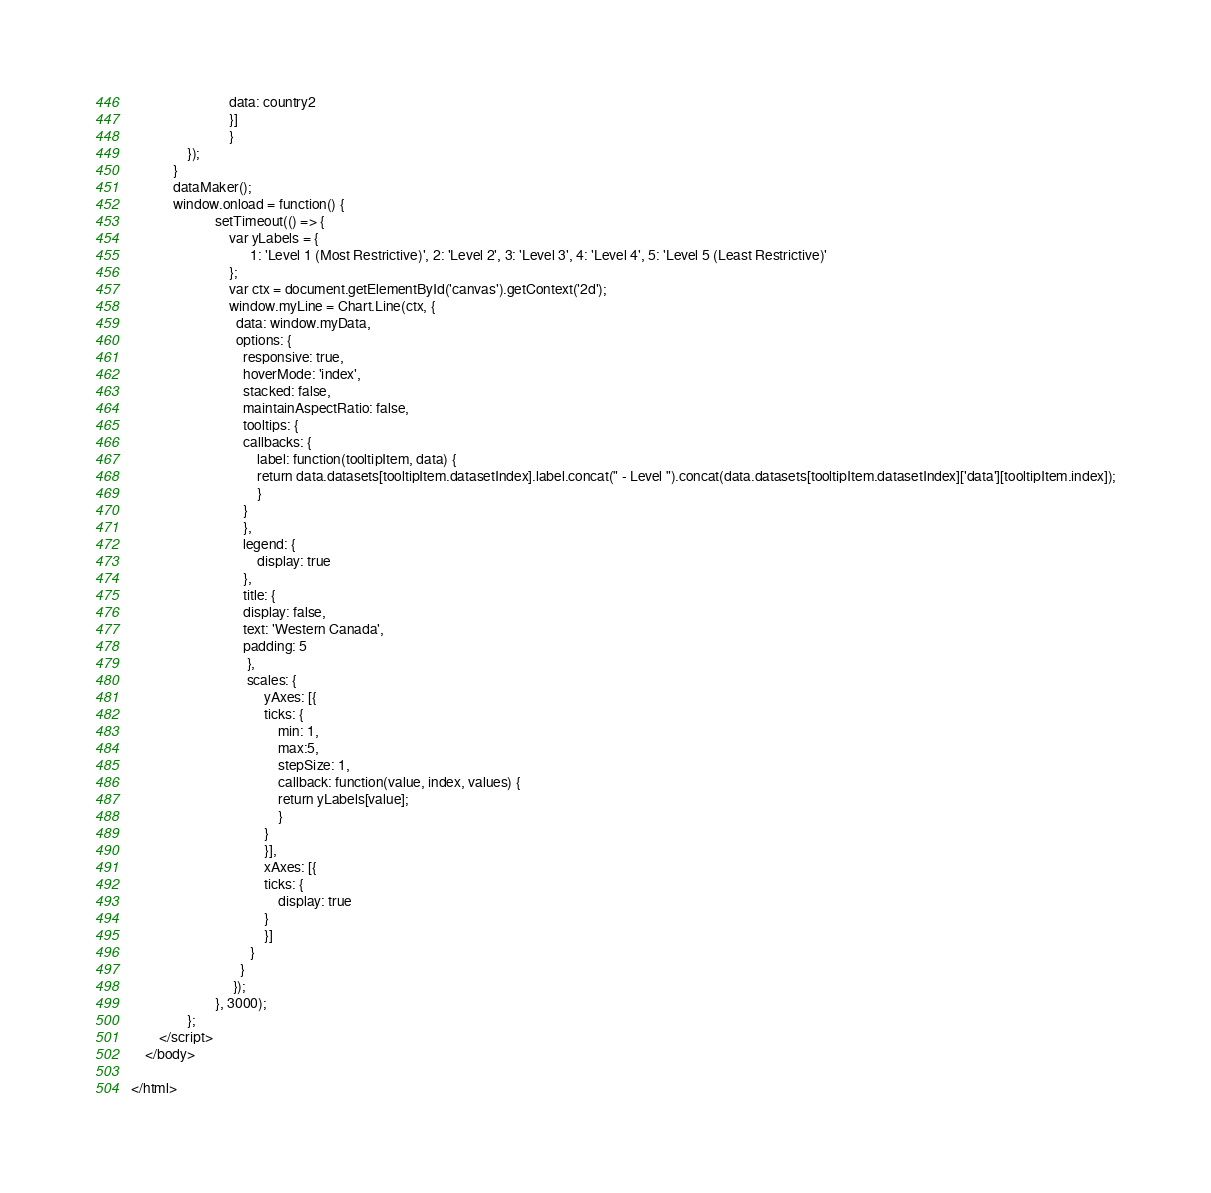<code> <loc_0><loc_0><loc_500><loc_500><_HTML_>						    data: country2
						    }]
						    }  
				});
			}
			dataMaker();
			window.onload = function() {
						setTimeout(() => { 
							var yLabels = {
							      1: 'Level 1 (Most Restrictive)', 2: 'Level 2', 3: 'Level 3', 4: 'Level 4', 5: 'Level 5 (Least Restrictive)'
							};
							var ctx = document.getElementById('canvas').getContext('2d');
							window.myLine = Chart.Line(ctx, {
							  data: window.myData,
							  options: {
							    responsive: true,
							    hoverMode: 'index',
							    stacked: false,
							    maintainAspectRatio: false,
							    tooltips: {
								callbacks: {
								    label: function(tooltipItem, data) {
									return data.datasets[tooltipItem.datasetIndex].label.concat(" - Level ").concat(data.datasets[tooltipItem.datasetIndex]['data'][tooltipItem.index]);
								    }
								}
							    },
							    legend: {
								    display: true
							    },
							    title: {
								display: false,
								text: 'Western Canada',
								padding: 5
							     },
							     scales: {
								      yAxes: [{
									  ticks: {
									      min: 1,
									      max:5,
									      stepSize: 1,
									      callback: function(value, index, values) {
										  return yLabels[value];
									      }
									  }
								      }],
								      xAxes: [{
									  ticks: {
									      display: true
									  }
								      }]
								  }
							   }
							 });
						}, 3000);
				};
		</script>
	</body>

</html></code> 